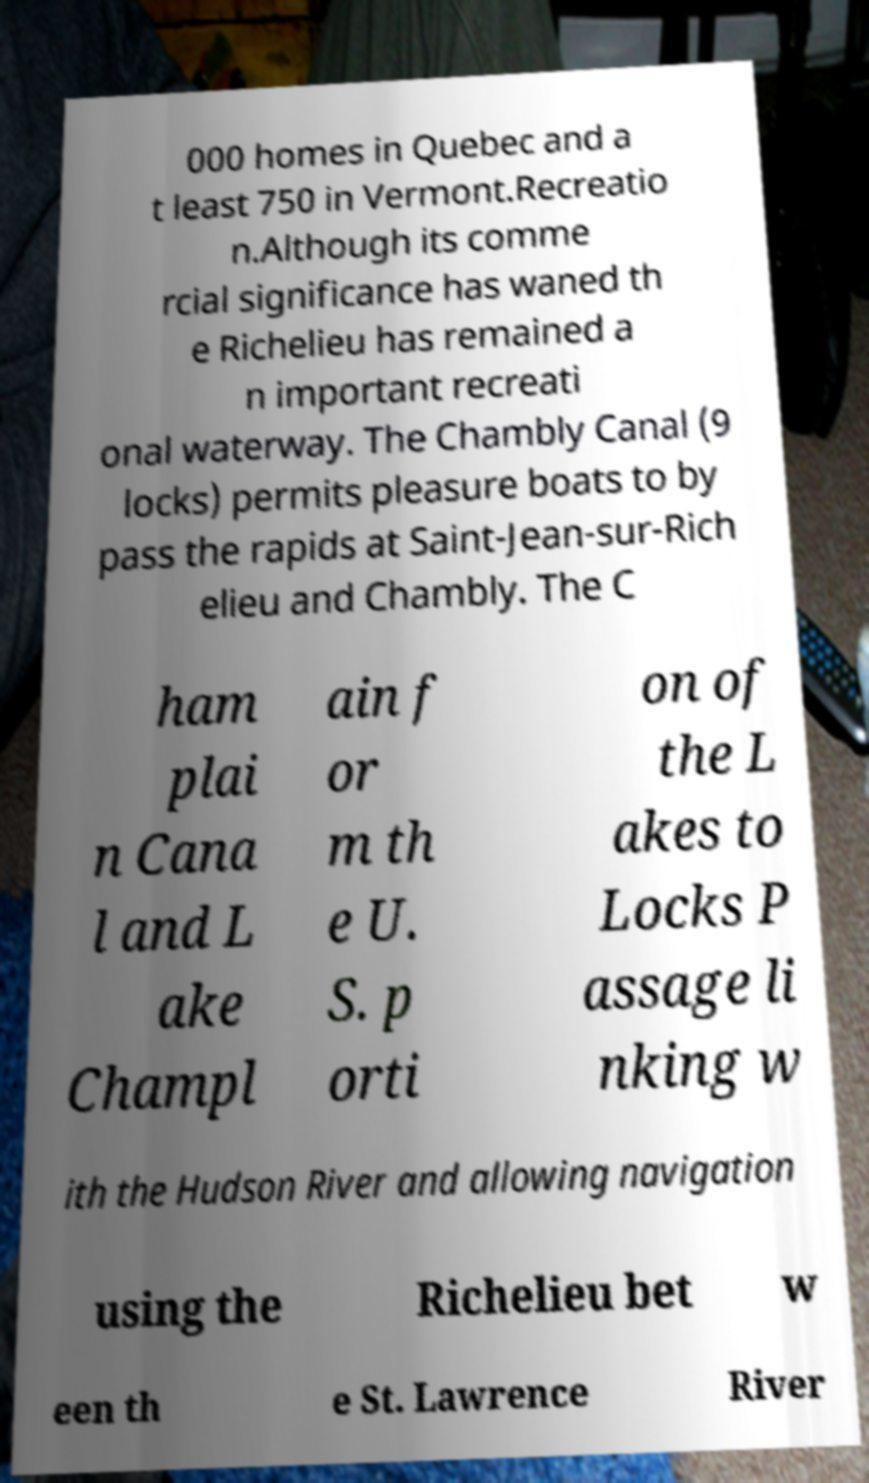Please read and relay the text visible in this image. What does it say? 000 homes in Quebec and a t least 750 in Vermont.Recreatio n.Although its comme rcial significance has waned th e Richelieu has remained a n important recreati onal waterway. The Chambly Canal (9 locks) permits pleasure boats to by pass the rapids at Saint-Jean-sur-Rich elieu and Chambly. The C ham plai n Cana l and L ake Champl ain f or m th e U. S. p orti on of the L akes to Locks P assage li nking w ith the Hudson River and allowing navigation using the Richelieu bet w een th e St. Lawrence River 